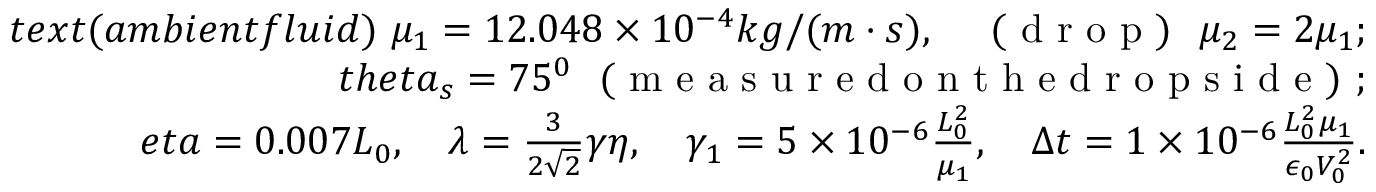<formula> <loc_0><loc_0><loc_500><loc_500>\begin{array} { r l } { t e x t { ( a m b i e n t f l u i d ) } \ \mu _ { 1 } = 1 2 . 0 4 8 \times 1 0 ^ { - 4 } k g / ( m \cdot s ) , \quad ( d r o p ) \ \mu _ { 2 } = 2 \mu _ { 1 } ; } \\ { t h e t a _ { s } = 7 5 ^ { 0 } \ ( m e a s u r e d o n t h e d r o p s i d e ) ; } \\ { e t a = 0 . 0 0 7 L _ { 0 } , \quad \lambda = \frac { 3 } { 2 \sqrt { 2 } } \gamma \eta , \quad \gamma _ { 1 } = 5 \times 1 0 ^ { - 6 } \frac { L _ { 0 } ^ { 2 } } { \mu _ { 1 } } , \quad \Delta t = 1 \times 1 0 ^ { - 6 } \frac { L _ { 0 } ^ { 2 } \mu _ { 1 } } { \epsilon _ { 0 } V _ { 0 } ^ { 2 } } . } \end{array}</formula> 